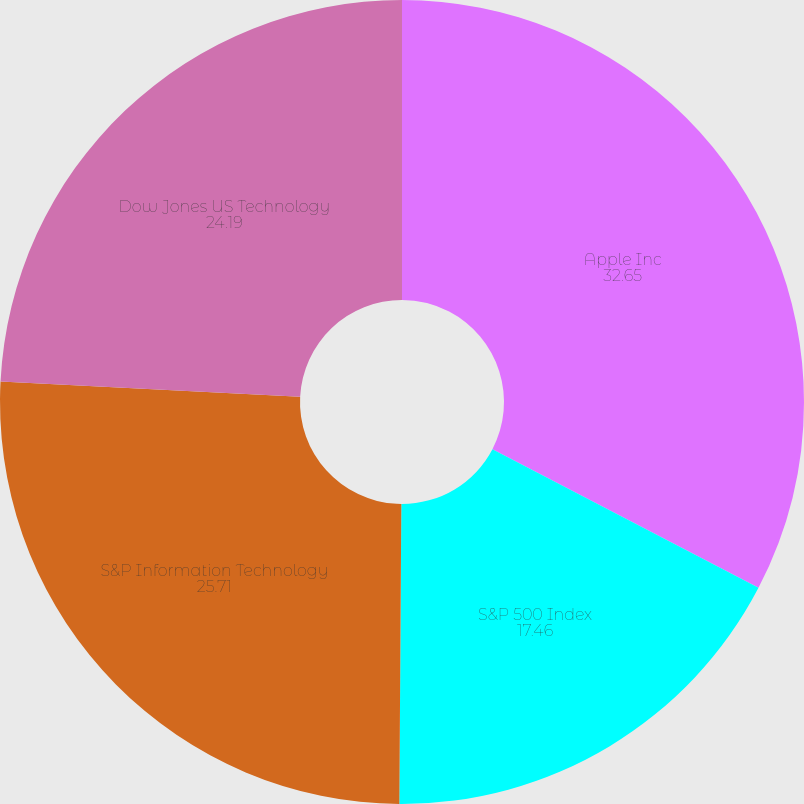Convert chart. <chart><loc_0><loc_0><loc_500><loc_500><pie_chart><fcel>Apple Inc<fcel>S&P 500 Index<fcel>S&P Information Technology<fcel>Dow Jones US Technology<nl><fcel>32.65%<fcel>17.46%<fcel>25.71%<fcel>24.19%<nl></chart> 